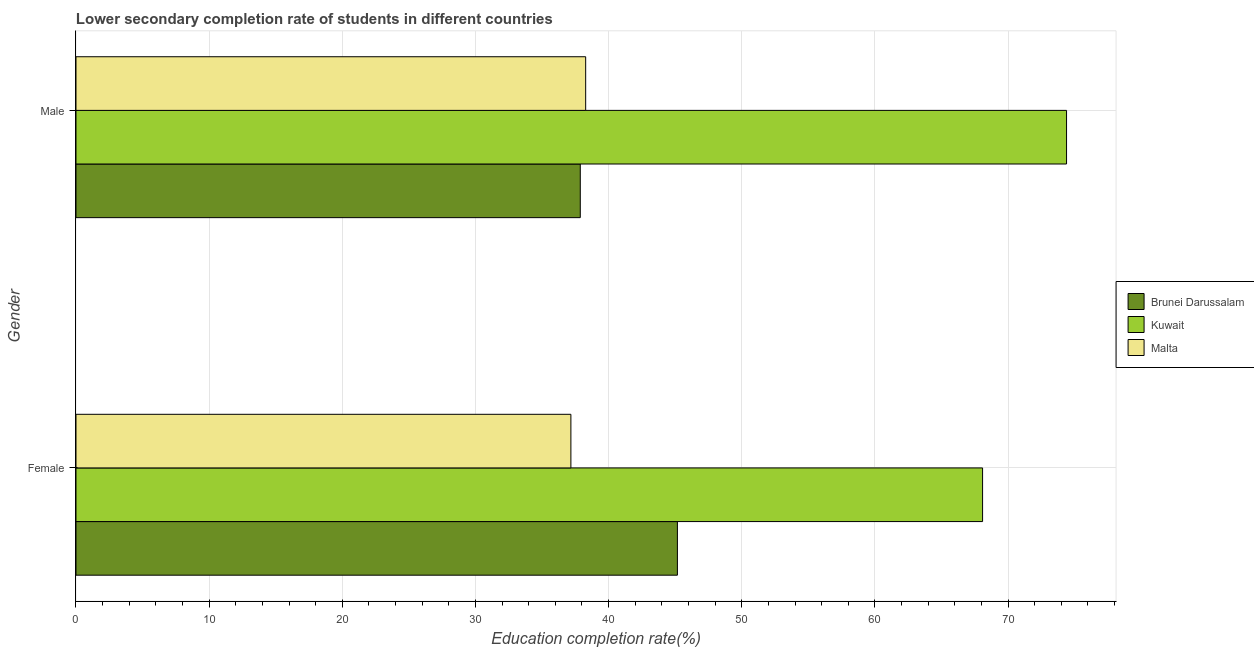How many groups of bars are there?
Your answer should be very brief. 2. Are the number of bars per tick equal to the number of legend labels?
Offer a terse response. Yes. How many bars are there on the 1st tick from the top?
Your answer should be compact. 3. How many bars are there on the 1st tick from the bottom?
Offer a very short reply. 3. What is the label of the 1st group of bars from the top?
Give a very brief answer. Male. What is the education completion rate of female students in Brunei Darussalam?
Provide a succinct answer. 45.17. Across all countries, what is the maximum education completion rate of male students?
Offer a terse response. 74.39. Across all countries, what is the minimum education completion rate of female students?
Ensure brevity in your answer.  37.17. In which country was the education completion rate of female students maximum?
Ensure brevity in your answer.  Kuwait. In which country was the education completion rate of female students minimum?
Your answer should be very brief. Malta. What is the total education completion rate of male students in the graph?
Ensure brevity in your answer.  150.55. What is the difference between the education completion rate of male students in Brunei Darussalam and that in Malta?
Ensure brevity in your answer.  -0.4. What is the difference between the education completion rate of male students in Brunei Darussalam and the education completion rate of female students in Malta?
Give a very brief answer. 0.7. What is the average education completion rate of male students per country?
Your answer should be compact. 50.18. What is the difference between the education completion rate of female students and education completion rate of male students in Brunei Darussalam?
Offer a terse response. 7.29. What is the ratio of the education completion rate of female students in Brunei Darussalam to that in Malta?
Provide a succinct answer. 1.22. In how many countries, is the education completion rate of female students greater than the average education completion rate of female students taken over all countries?
Your answer should be compact. 1. What does the 3rd bar from the top in Male represents?
Provide a succinct answer. Brunei Darussalam. What does the 3rd bar from the bottom in Male represents?
Keep it short and to the point. Malta. How many bars are there?
Keep it short and to the point. 6. Are all the bars in the graph horizontal?
Offer a terse response. Yes. Are the values on the major ticks of X-axis written in scientific E-notation?
Your response must be concise. No. Does the graph contain any zero values?
Ensure brevity in your answer.  No. Does the graph contain grids?
Offer a very short reply. Yes. Where does the legend appear in the graph?
Provide a short and direct response. Center right. How many legend labels are there?
Your answer should be very brief. 3. How are the legend labels stacked?
Make the answer very short. Vertical. What is the title of the graph?
Your response must be concise. Lower secondary completion rate of students in different countries. What is the label or title of the X-axis?
Keep it short and to the point. Education completion rate(%). What is the label or title of the Y-axis?
Provide a succinct answer. Gender. What is the Education completion rate(%) of Brunei Darussalam in Female?
Your answer should be very brief. 45.17. What is the Education completion rate(%) in Kuwait in Female?
Ensure brevity in your answer.  68.09. What is the Education completion rate(%) in Malta in Female?
Offer a very short reply. 37.17. What is the Education completion rate(%) in Brunei Darussalam in Male?
Offer a terse response. 37.87. What is the Education completion rate(%) in Kuwait in Male?
Offer a very short reply. 74.39. What is the Education completion rate(%) of Malta in Male?
Offer a terse response. 38.28. Across all Gender, what is the maximum Education completion rate(%) in Brunei Darussalam?
Ensure brevity in your answer.  45.17. Across all Gender, what is the maximum Education completion rate(%) of Kuwait?
Offer a terse response. 74.39. Across all Gender, what is the maximum Education completion rate(%) of Malta?
Give a very brief answer. 38.28. Across all Gender, what is the minimum Education completion rate(%) of Brunei Darussalam?
Offer a terse response. 37.87. Across all Gender, what is the minimum Education completion rate(%) in Kuwait?
Ensure brevity in your answer.  68.09. Across all Gender, what is the minimum Education completion rate(%) in Malta?
Your answer should be compact. 37.17. What is the total Education completion rate(%) of Brunei Darussalam in the graph?
Provide a succinct answer. 83.04. What is the total Education completion rate(%) in Kuwait in the graph?
Your response must be concise. 142.48. What is the total Education completion rate(%) in Malta in the graph?
Provide a succinct answer. 75.45. What is the difference between the Education completion rate(%) of Brunei Darussalam in Female and that in Male?
Your answer should be compact. 7.29. What is the difference between the Education completion rate(%) of Kuwait in Female and that in Male?
Your response must be concise. -6.31. What is the difference between the Education completion rate(%) in Malta in Female and that in Male?
Your answer should be compact. -1.11. What is the difference between the Education completion rate(%) of Brunei Darussalam in Female and the Education completion rate(%) of Kuwait in Male?
Provide a succinct answer. -29.23. What is the difference between the Education completion rate(%) in Brunei Darussalam in Female and the Education completion rate(%) in Malta in Male?
Give a very brief answer. 6.89. What is the difference between the Education completion rate(%) of Kuwait in Female and the Education completion rate(%) of Malta in Male?
Your answer should be very brief. 29.81. What is the average Education completion rate(%) in Brunei Darussalam per Gender?
Provide a short and direct response. 41.52. What is the average Education completion rate(%) in Kuwait per Gender?
Offer a terse response. 71.24. What is the average Education completion rate(%) in Malta per Gender?
Provide a short and direct response. 37.72. What is the difference between the Education completion rate(%) of Brunei Darussalam and Education completion rate(%) of Kuwait in Female?
Offer a very short reply. -22.92. What is the difference between the Education completion rate(%) of Brunei Darussalam and Education completion rate(%) of Malta in Female?
Give a very brief answer. 8. What is the difference between the Education completion rate(%) in Kuwait and Education completion rate(%) in Malta in Female?
Your response must be concise. 30.92. What is the difference between the Education completion rate(%) of Brunei Darussalam and Education completion rate(%) of Kuwait in Male?
Ensure brevity in your answer.  -36.52. What is the difference between the Education completion rate(%) of Brunei Darussalam and Education completion rate(%) of Malta in Male?
Offer a very short reply. -0.4. What is the difference between the Education completion rate(%) of Kuwait and Education completion rate(%) of Malta in Male?
Provide a succinct answer. 36.12. What is the ratio of the Education completion rate(%) in Brunei Darussalam in Female to that in Male?
Offer a terse response. 1.19. What is the ratio of the Education completion rate(%) of Kuwait in Female to that in Male?
Give a very brief answer. 0.92. What is the ratio of the Education completion rate(%) of Malta in Female to that in Male?
Make the answer very short. 0.97. What is the difference between the highest and the second highest Education completion rate(%) in Brunei Darussalam?
Your answer should be compact. 7.29. What is the difference between the highest and the second highest Education completion rate(%) in Kuwait?
Provide a succinct answer. 6.31. What is the difference between the highest and the second highest Education completion rate(%) of Malta?
Your answer should be compact. 1.11. What is the difference between the highest and the lowest Education completion rate(%) in Brunei Darussalam?
Keep it short and to the point. 7.29. What is the difference between the highest and the lowest Education completion rate(%) of Kuwait?
Ensure brevity in your answer.  6.31. What is the difference between the highest and the lowest Education completion rate(%) in Malta?
Offer a terse response. 1.11. 